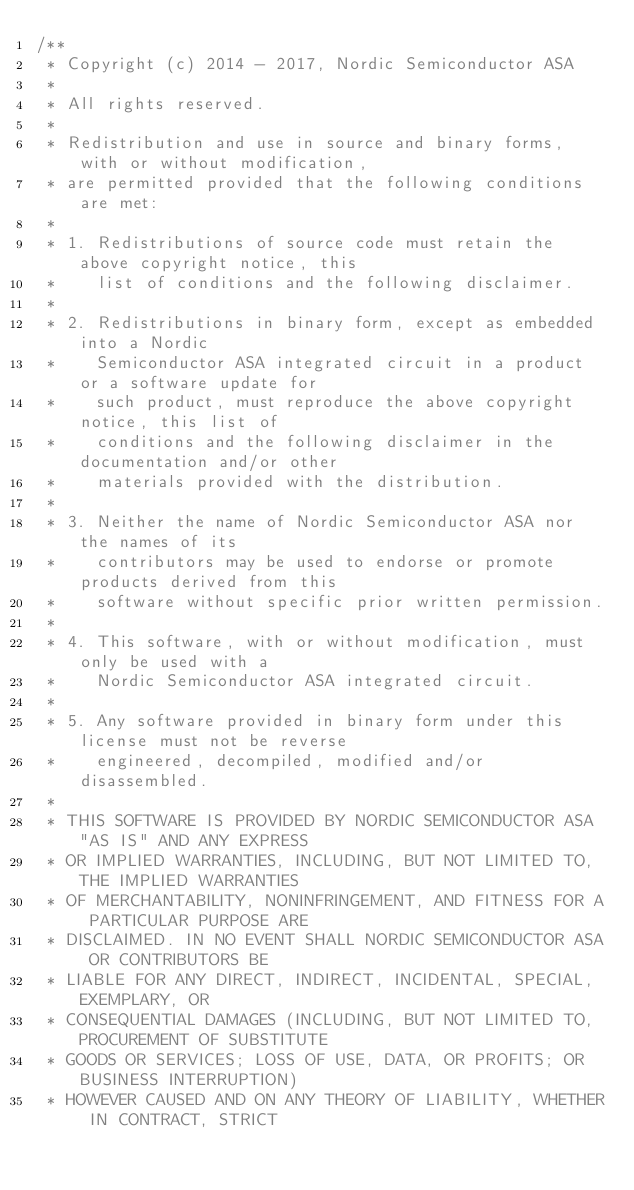Convert code to text. <code><loc_0><loc_0><loc_500><loc_500><_C_>/**
 * Copyright (c) 2014 - 2017, Nordic Semiconductor ASA
 * 
 * All rights reserved.
 * 
 * Redistribution and use in source and binary forms, with or without modification,
 * are permitted provided that the following conditions are met:
 * 
 * 1. Redistributions of source code must retain the above copyright notice, this
 *    list of conditions and the following disclaimer.
 * 
 * 2. Redistributions in binary form, except as embedded into a Nordic
 *    Semiconductor ASA integrated circuit in a product or a software update for
 *    such product, must reproduce the above copyright notice, this list of
 *    conditions and the following disclaimer in the documentation and/or other
 *    materials provided with the distribution.
 * 
 * 3. Neither the name of Nordic Semiconductor ASA nor the names of its
 *    contributors may be used to endorse or promote products derived from this
 *    software without specific prior written permission.
 * 
 * 4. This software, with or without modification, must only be used with a
 *    Nordic Semiconductor ASA integrated circuit.
 * 
 * 5. Any software provided in binary form under this license must not be reverse
 *    engineered, decompiled, modified and/or disassembled.
 * 
 * THIS SOFTWARE IS PROVIDED BY NORDIC SEMICONDUCTOR ASA "AS IS" AND ANY EXPRESS
 * OR IMPLIED WARRANTIES, INCLUDING, BUT NOT LIMITED TO, THE IMPLIED WARRANTIES
 * OF MERCHANTABILITY, NONINFRINGEMENT, AND FITNESS FOR A PARTICULAR PURPOSE ARE
 * DISCLAIMED. IN NO EVENT SHALL NORDIC SEMICONDUCTOR ASA OR CONTRIBUTORS BE
 * LIABLE FOR ANY DIRECT, INDIRECT, INCIDENTAL, SPECIAL, EXEMPLARY, OR
 * CONSEQUENTIAL DAMAGES (INCLUDING, BUT NOT LIMITED TO, PROCUREMENT OF SUBSTITUTE
 * GOODS OR SERVICES; LOSS OF USE, DATA, OR PROFITS; OR BUSINESS INTERRUPTION)
 * HOWEVER CAUSED AND ON ANY THEORY OF LIABILITY, WHETHER IN CONTRACT, STRICT</code> 